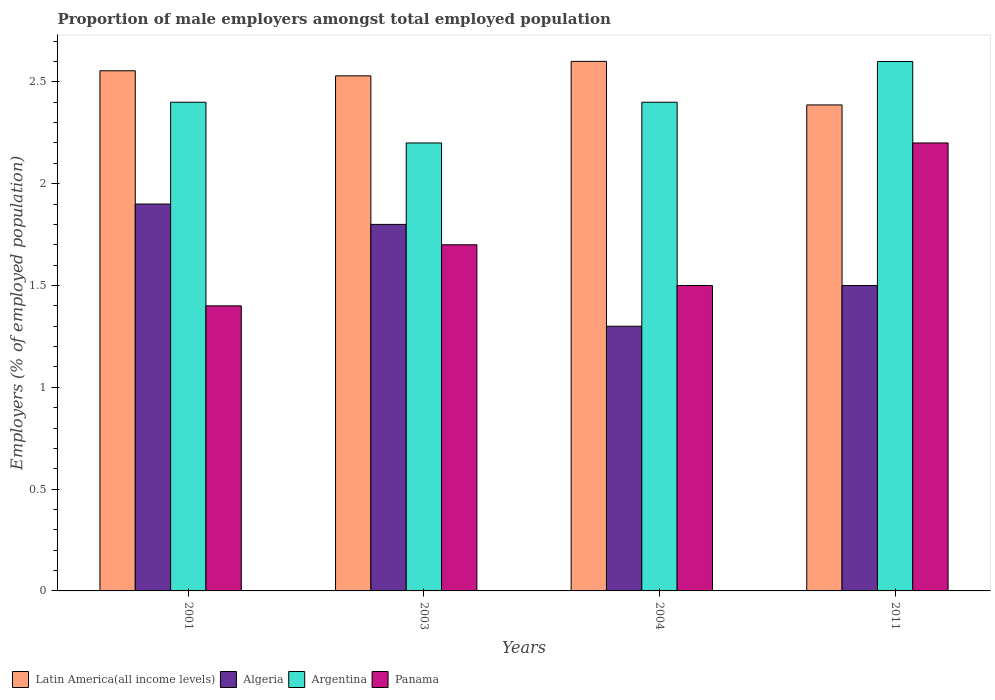How many groups of bars are there?
Offer a terse response. 4. Are the number of bars per tick equal to the number of legend labels?
Provide a succinct answer. Yes. What is the label of the 4th group of bars from the left?
Your response must be concise. 2011. What is the proportion of male employers in Panama in 2003?
Give a very brief answer. 1.7. Across all years, what is the maximum proportion of male employers in Argentina?
Offer a terse response. 2.6. Across all years, what is the minimum proportion of male employers in Argentina?
Make the answer very short. 2.2. In which year was the proportion of male employers in Algeria maximum?
Provide a succinct answer. 2001. In which year was the proportion of male employers in Argentina minimum?
Your response must be concise. 2003. What is the total proportion of male employers in Panama in the graph?
Ensure brevity in your answer.  6.8. What is the difference between the proportion of male employers in Panama in 2003 and that in 2011?
Your answer should be compact. -0.5. What is the difference between the proportion of male employers in Algeria in 2011 and the proportion of male employers in Latin America(all income levels) in 2003?
Offer a terse response. -1.03. What is the average proportion of male employers in Algeria per year?
Make the answer very short. 1.62. In the year 2004, what is the difference between the proportion of male employers in Panama and proportion of male employers in Algeria?
Ensure brevity in your answer.  0.2. What is the ratio of the proportion of male employers in Argentina in 2003 to that in 2011?
Offer a very short reply. 0.85. What is the difference between the highest and the second highest proportion of male employers in Argentina?
Provide a short and direct response. 0.2. What is the difference between the highest and the lowest proportion of male employers in Latin America(all income levels)?
Offer a very short reply. 0.21. What does the 3rd bar from the right in 2004 represents?
Keep it short and to the point. Algeria. Is it the case that in every year, the sum of the proportion of male employers in Argentina and proportion of male employers in Latin America(all income levels) is greater than the proportion of male employers in Panama?
Ensure brevity in your answer.  Yes. How many bars are there?
Offer a very short reply. 16. Are all the bars in the graph horizontal?
Offer a very short reply. No. Are the values on the major ticks of Y-axis written in scientific E-notation?
Give a very brief answer. No. Does the graph contain any zero values?
Keep it short and to the point. No. How are the legend labels stacked?
Your answer should be compact. Horizontal. What is the title of the graph?
Offer a terse response. Proportion of male employers amongst total employed population. Does "Latin America(developing only)" appear as one of the legend labels in the graph?
Offer a terse response. No. What is the label or title of the X-axis?
Ensure brevity in your answer.  Years. What is the label or title of the Y-axis?
Offer a terse response. Employers (% of employed population). What is the Employers (% of employed population) of Latin America(all income levels) in 2001?
Keep it short and to the point. 2.55. What is the Employers (% of employed population) of Algeria in 2001?
Provide a succinct answer. 1.9. What is the Employers (% of employed population) of Argentina in 2001?
Your answer should be very brief. 2.4. What is the Employers (% of employed population) in Panama in 2001?
Provide a short and direct response. 1.4. What is the Employers (% of employed population) of Latin America(all income levels) in 2003?
Provide a succinct answer. 2.53. What is the Employers (% of employed population) of Algeria in 2003?
Ensure brevity in your answer.  1.8. What is the Employers (% of employed population) of Argentina in 2003?
Make the answer very short. 2.2. What is the Employers (% of employed population) of Panama in 2003?
Offer a very short reply. 1.7. What is the Employers (% of employed population) in Latin America(all income levels) in 2004?
Provide a short and direct response. 2.6. What is the Employers (% of employed population) in Algeria in 2004?
Your response must be concise. 1.3. What is the Employers (% of employed population) of Argentina in 2004?
Ensure brevity in your answer.  2.4. What is the Employers (% of employed population) in Latin America(all income levels) in 2011?
Your answer should be compact. 2.39. What is the Employers (% of employed population) of Argentina in 2011?
Offer a terse response. 2.6. What is the Employers (% of employed population) in Panama in 2011?
Give a very brief answer. 2.2. Across all years, what is the maximum Employers (% of employed population) in Latin America(all income levels)?
Provide a short and direct response. 2.6. Across all years, what is the maximum Employers (% of employed population) of Algeria?
Offer a very short reply. 1.9. Across all years, what is the maximum Employers (% of employed population) in Argentina?
Keep it short and to the point. 2.6. Across all years, what is the maximum Employers (% of employed population) in Panama?
Your answer should be compact. 2.2. Across all years, what is the minimum Employers (% of employed population) of Latin America(all income levels)?
Your response must be concise. 2.39. Across all years, what is the minimum Employers (% of employed population) in Algeria?
Your answer should be compact. 1.3. Across all years, what is the minimum Employers (% of employed population) in Argentina?
Provide a succinct answer. 2.2. Across all years, what is the minimum Employers (% of employed population) of Panama?
Give a very brief answer. 1.4. What is the total Employers (% of employed population) in Latin America(all income levels) in the graph?
Offer a very short reply. 10.07. What is the total Employers (% of employed population) of Algeria in the graph?
Provide a succinct answer. 6.5. What is the total Employers (% of employed population) of Argentina in the graph?
Provide a succinct answer. 9.6. What is the difference between the Employers (% of employed population) in Latin America(all income levels) in 2001 and that in 2003?
Your answer should be very brief. 0.03. What is the difference between the Employers (% of employed population) of Panama in 2001 and that in 2003?
Offer a very short reply. -0.3. What is the difference between the Employers (% of employed population) in Latin America(all income levels) in 2001 and that in 2004?
Make the answer very short. -0.05. What is the difference between the Employers (% of employed population) of Algeria in 2001 and that in 2004?
Give a very brief answer. 0.6. What is the difference between the Employers (% of employed population) of Latin America(all income levels) in 2001 and that in 2011?
Keep it short and to the point. 0.17. What is the difference between the Employers (% of employed population) of Algeria in 2001 and that in 2011?
Offer a very short reply. 0.4. What is the difference between the Employers (% of employed population) of Panama in 2001 and that in 2011?
Your answer should be compact. -0.8. What is the difference between the Employers (% of employed population) of Latin America(all income levels) in 2003 and that in 2004?
Your answer should be compact. -0.07. What is the difference between the Employers (% of employed population) in Argentina in 2003 and that in 2004?
Ensure brevity in your answer.  -0.2. What is the difference between the Employers (% of employed population) in Panama in 2003 and that in 2004?
Keep it short and to the point. 0.2. What is the difference between the Employers (% of employed population) in Latin America(all income levels) in 2003 and that in 2011?
Provide a succinct answer. 0.14. What is the difference between the Employers (% of employed population) of Algeria in 2003 and that in 2011?
Provide a succinct answer. 0.3. What is the difference between the Employers (% of employed population) in Argentina in 2003 and that in 2011?
Offer a terse response. -0.4. What is the difference between the Employers (% of employed population) of Panama in 2003 and that in 2011?
Keep it short and to the point. -0.5. What is the difference between the Employers (% of employed population) of Latin America(all income levels) in 2004 and that in 2011?
Your answer should be very brief. 0.21. What is the difference between the Employers (% of employed population) of Argentina in 2004 and that in 2011?
Give a very brief answer. -0.2. What is the difference between the Employers (% of employed population) of Latin America(all income levels) in 2001 and the Employers (% of employed population) of Algeria in 2003?
Your answer should be compact. 0.75. What is the difference between the Employers (% of employed population) in Latin America(all income levels) in 2001 and the Employers (% of employed population) in Argentina in 2003?
Your response must be concise. 0.35. What is the difference between the Employers (% of employed population) in Latin America(all income levels) in 2001 and the Employers (% of employed population) in Panama in 2003?
Ensure brevity in your answer.  0.85. What is the difference between the Employers (% of employed population) of Algeria in 2001 and the Employers (% of employed population) of Panama in 2003?
Offer a very short reply. 0.2. What is the difference between the Employers (% of employed population) of Latin America(all income levels) in 2001 and the Employers (% of employed population) of Algeria in 2004?
Keep it short and to the point. 1.25. What is the difference between the Employers (% of employed population) of Latin America(all income levels) in 2001 and the Employers (% of employed population) of Argentina in 2004?
Provide a succinct answer. 0.15. What is the difference between the Employers (% of employed population) of Latin America(all income levels) in 2001 and the Employers (% of employed population) of Panama in 2004?
Offer a very short reply. 1.05. What is the difference between the Employers (% of employed population) of Algeria in 2001 and the Employers (% of employed population) of Argentina in 2004?
Ensure brevity in your answer.  -0.5. What is the difference between the Employers (% of employed population) of Latin America(all income levels) in 2001 and the Employers (% of employed population) of Algeria in 2011?
Make the answer very short. 1.05. What is the difference between the Employers (% of employed population) in Latin America(all income levels) in 2001 and the Employers (% of employed population) in Argentina in 2011?
Your answer should be compact. -0.05. What is the difference between the Employers (% of employed population) of Latin America(all income levels) in 2001 and the Employers (% of employed population) of Panama in 2011?
Offer a very short reply. 0.35. What is the difference between the Employers (% of employed population) in Algeria in 2001 and the Employers (% of employed population) in Argentina in 2011?
Ensure brevity in your answer.  -0.7. What is the difference between the Employers (% of employed population) of Argentina in 2001 and the Employers (% of employed population) of Panama in 2011?
Offer a very short reply. 0.2. What is the difference between the Employers (% of employed population) in Latin America(all income levels) in 2003 and the Employers (% of employed population) in Algeria in 2004?
Give a very brief answer. 1.23. What is the difference between the Employers (% of employed population) in Latin America(all income levels) in 2003 and the Employers (% of employed population) in Argentina in 2004?
Your answer should be very brief. 0.13. What is the difference between the Employers (% of employed population) of Latin America(all income levels) in 2003 and the Employers (% of employed population) of Panama in 2004?
Your answer should be compact. 1.03. What is the difference between the Employers (% of employed population) of Algeria in 2003 and the Employers (% of employed population) of Argentina in 2004?
Provide a short and direct response. -0.6. What is the difference between the Employers (% of employed population) in Latin America(all income levels) in 2003 and the Employers (% of employed population) in Algeria in 2011?
Ensure brevity in your answer.  1.03. What is the difference between the Employers (% of employed population) in Latin America(all income levels) in 2003 and the Employers (% of employed population) in Argentina in 2011?
Your response must be concise. -0.07. What is the difference between the Employers (% of employed population) in Latin America(all income levels) in 2003 and the Employers (% of employed population) in Panama in 2011?
Keep it short and to the point. 0.33. What is the difference between the Employers (% of employed population) in Latin America(all income levels) in 2004 and the Employers (% of employed population) in Algeria in 2011?
Your answer should be compact. 1.1. What is the difference between the Employers (% of employed population) in Latin America(all income levels) in 2004 and the Employers (% of employed population) in Argentina in 2011?
Offer a very short reply. 0. What is the difference between the Employers (% of employed population) of Latin America(all income levels) in 2004 and the Employers (% of employed population) of Panama in 2011?
Give a very brief answer. 0.4. What is the difference between the Employers (% of employed population) in Algeria in 2004 and the Employers (% of employed population) in Argentina in 2011?
Offer a terse response. -1.3. What is the difference between the Employers (% of employed population) of Algeria in 2004 and the Employers (% of employed population) of Panama in 2011?
Provide a short and direct response. -0.9. What is the difference between the Employers (% of employed population) in Argentina in 2004 and the Employers (% of employed population) in Panama in 2011?
Give a very brief answer. 0.2. What is the average Employers (% of employed population) of Latin America(all income levels) per year?
Provide a short and direct response. 2.52. What is the average Employers (% of employed population) of Algeria per year?
Provide a succinct answer. 1.62. What is the average Employers (% of employed population) of Argentina per year?
Provide a succinct answer. 2.4. What is the average Employers (% of employed population) in Panama per year?
Your answer should be very brief. 1.7. In the year 2001, what is the difference between the Employers (% of employed population) of Latin America(all income levels) and Employers (% of employed population) of Algeria?
Provide a short and direct response. 0.65. In the year 2001, what is the difference between the Employers (% of employed population) in Latin America(all income levels) and Employers (% of employed population) in Argentina?
Give a very brief answer. 0.15. In the year 2001, what is the difference between the Employers (% of employed population) of Latin America(all income levels) and Employers (% of employed population) of Panama?
Your response must be concise. 1.15. In the year 2001, what is the difference between the Employers (% of employed population) in Algeria and Employers (% of employed population) in Argentina?
Your answer should be very brief. -0.5. In the year 2001, what is the difference between the Employers (% of employed population) of Algeria and Employers (% of employed population) of Panama?
Ensure brevity in your answer.  0.5. In the year 2003, what is the difference between the Employers (% of employed population) of Latin America(all income levels) and Employers (% of employed population) of Algeria?
Offer a very short reply. 0.73. In the year 2003, what is the difference between the Employers (% of employed population) in Latin America(all income levels) and Employers (% of employed population) in Argentina?
Give a very brief answer. 0.33. In the year 2003, what is the difference between the Employers (% of employed population) of Latin America(all income levels) and Employers (% of employed population) of Panama?
Give a very brief answer. 0.83. In the year 2003, what is the difference between the Employers (% of employed population) of Argentina and Employers (% of employed population) of Panama?
Offer a terse response. 0.5. In the year 2004, what is the difference between the Employers (% of employed population) in Latin America(all income levels) and Employers (% of employed population) in Algeria?
Your answer should be very brief. 1.3. In the year 2004, what is the difference between the Employers (% of employed population) of Latin America(all income levels) and Employers (% of employed population) of Argentina?
Provide a short and direct response. 0.2. In the year 2004, what is the difference between the Employers (% of employed population) in Latin America(all income levels) and Employers (% of employed population) in Panama?
Ensure brevity in your answer.  1.1. In the year 2004, what is the difference between the Employers (% of employed population) of Argentina and Employers (% of employed population) of Panama?
Provide a succinct answer. 0.9. In the year 2011, what is the difference between the Employers (% of employed population) in Latin America(all income levels) and Employers (% of employed population) in Algeria?
Offer a terse response. 0.89. In the year 2011, what is the difference between the Employers (% of employed population) in Latin America(all income levels) and Employers (% of employed population) in Argentina?
Offer a terse response. -0.21. In the year 2011, what is the difference between the Employers (% of employed population) in Latin America(all income levels) and Employers (% of employed population) in Panama?
Offer a very short reply. 0.19. In the year 2011, what is the difference between the Employers (% of employed population) in Algeria and Employers (% of employed population) in Argentina?
Offer a terse response. -1.1. In the year 2011, what is the difference between the Employers (% of employed population) of Algeria and Employers (% of employed population) of Panama?
Your answer should be compact. -0.7. In the year 2011, what is the difference between the Employers (% of employed population) in Argentina and Employers (% of employed population) in Panama?
Offer a very short reply. 0.4. What is the ratio of the Employers (% of employed population) of Latin America(all income levels) in 2001 to that in 2003?
Provide a succinct answer. 1.01. What is the ratio of the Employers (% of employed population) of Algeria in 2001 to that in 2003?
Make the answer very short. 1.06. What is the ratio of the Employers (% of employed population) of Argentina in 2001 to that in 2003?
Provide a succinct answer. 1.09. What is the ratio of the Employers (% of employed population) of Panama in 2001 to that in 2003?
Provide a succinct answer. 0.82. What is the ratio of the Employers (% of employed population) of Latin America(all income levels) in 2001 to that in 2004?
Offer a very short reply. 0.98. What is the ratio of the Employers (% of employed population) in Algeria in 2001 to that in 2004?
Ensure brevity in your answer.  1.46. What is the ratio of the Employers (% of employed population) in Latin America(all income levels) in 2001 to that in 2011?
Your response must be concise. 1.07. What is the ratio of the Employers (% of employed population) of Algeria in 2001 to that in 2011?
Offer a terse response. 1.27. What is the ratio of the Employers (% of employed population) of Panama in 2001 to that in 2011?
Keep it short and to the point. 0.64. What is the ratio of the Employers (% of employed population) in Latin America(all income levels) in 2003 to that in 2004?
Keep it short and to the point. 0.97. What is the ratio of the Employers (% of employed population) of Algeria in 2003 to that in 2004?
Offer a very short reply. 1.38. What is the ratio of the Employers (% of employed population) in Argentina in 2003 to that in 2004?
Give a very brief answer. 0.92. What is the ratio of the Employers (% of employed population) in Panama in 2003 to that in 2004?
Give a very brief answer. 1.13. What is the ratio of the Employers (% of employed population) in Latin America(all income levels) in 2003 to that in 2011?
Give a very brief answer. 1.06. What is the ratio of the Employers (% of employed population) in Argentina in 2003 to that in 2011?
Your answer should be very brief. 0.85. What is the ratio of the Employers (% of employed population) in Panama in 2003 to that in 2011?
Offer a terse response. 0.77. What is the ratio of the Employers (% of employed population) in Latin America(all income levels) in 2004 to that in 2011?
Offer a very short reply. 1.09. What is the ratio of the Employers (% of employed population) of Algeria in 2004 to that in 2011?
Offer a terse response. 0.87. What is the ratio of the Employers (% of employed population) of Panama in 2004 to that in 2011?
Offer a very short reply. 0.68. What is the difference between the highest and the second highest Employers (% of employed population) of Latin America(all income levels)?
Your answer should be compact. 0.05. What is the difference between the highest and the second highest Employers (% of employed population) in Argentina?
Offer a very short reply. 0.2. What is the difference between the highest and the lowest Employers (% of employed population) of Latin America(all income levels)?
Make the answer very short. 0.21. What is the difference between the highest and the lowest Employers (% of employed population) in Panama?
Provide a succinct answer. 0.8. 